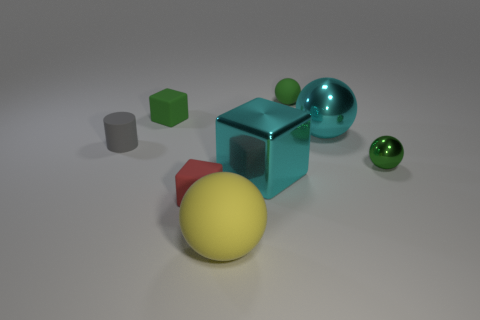How many tiny objects are either cyan balls or shiny objects?
Keep it short and to the point. 1. The tiny shiny object is what color?
Offer a terse response. Green. There is a green thing on the right side of the small green ball left of the tiny green metal object; what is its shape?
Provide a short and direct response. Sphere. Is there a large sphere made of the same material as the cylinder?
Provide a succinct answer. Yes. Is the size of the ball that is in front of the green metal ball the same as the tiny red matte block?
Your response must be concise. No. How many gray objects are either tiny matte cylinders or metallic objects?
Your response must be concise. 1. What is the material of the cyan cube on the right side of the gray matte object?
Keep it short and to the point. Metal. What number of gray rubber objects are behind the object that is left of the green block?
Ensure brevity in your answer.  0. How many tiny matte objects are the same shape as the large yellow rubber object?
Your answer should be very brief. 1. What number of small brown matte objects are there?
Provide a succinct answer. 0. 